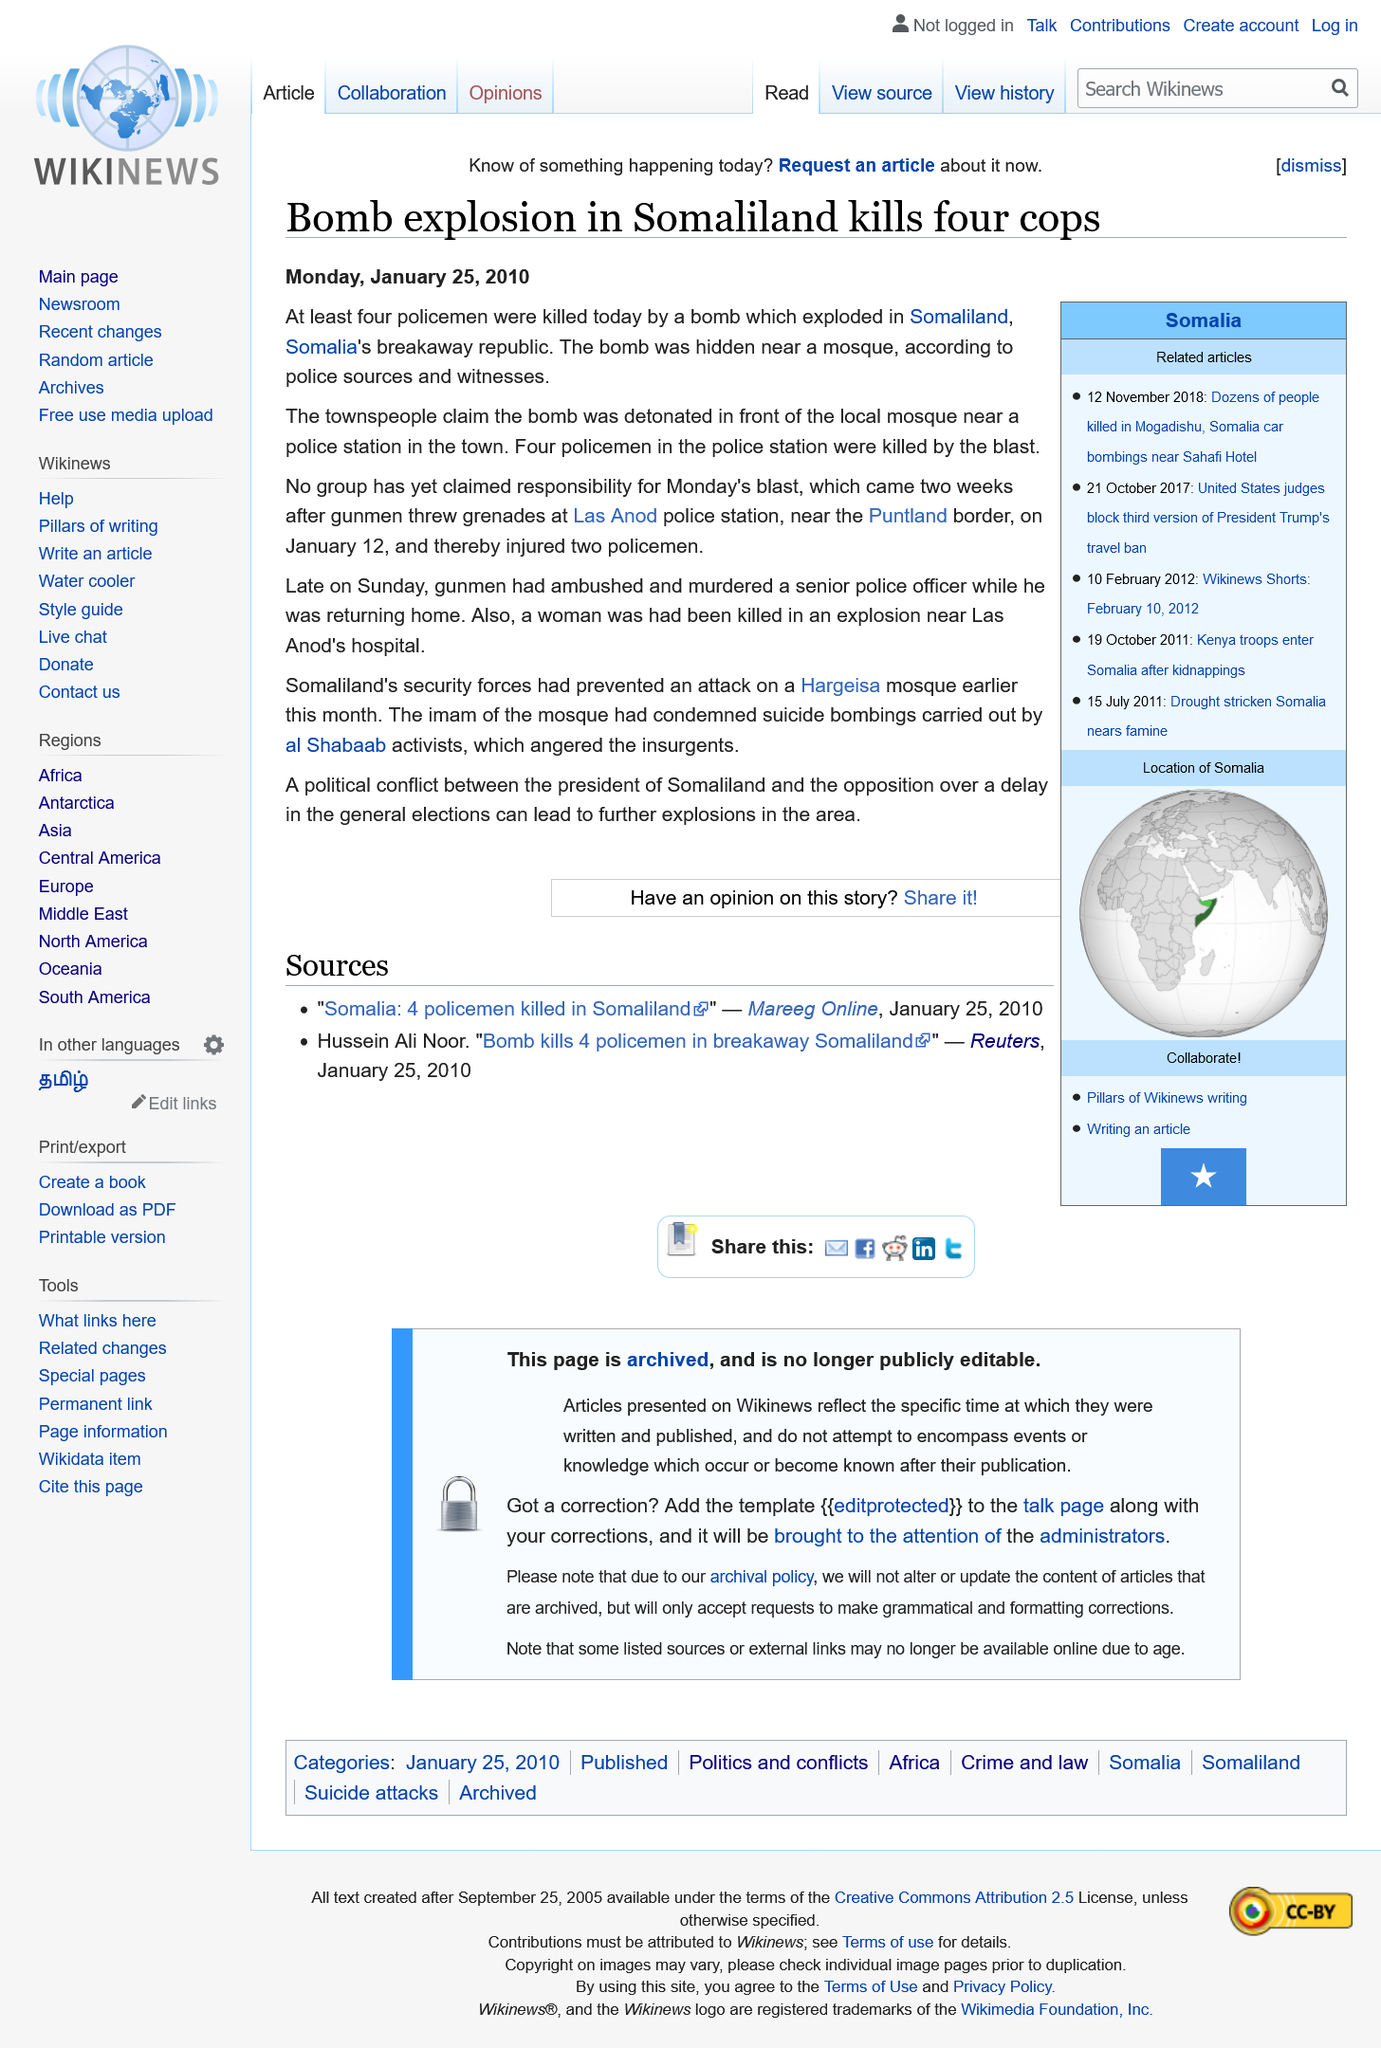Outline some significant characteristics in this image. In Somaliland, a bomb detonated in front of a local mosque, causing widespread destruction and loss of life. Four policemen were killed in the blast. The news article was published on Monday, January 25, 2010. 